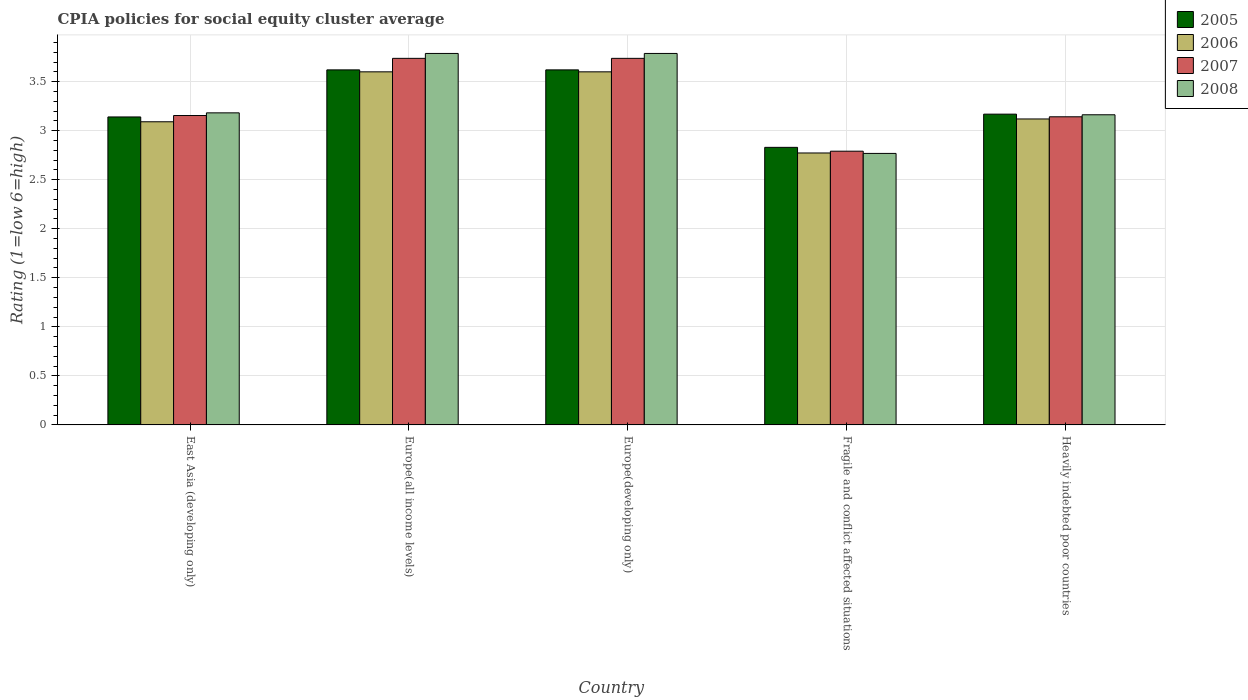How many different coloured bars are there?
Your response must be concise. 4. How many bars are there on the 4th tick from the left?
Provide a short and direct response. 4. How many bars are there on the 1st tick from the right?
Your answer should be compact. 4. What is the label of the 5th group of bars from the left?
Your response must be concise. Heavily indebted poor countries. In how many cases, is the number of bars for a given country not equal to the number of legend labels?
Offer a very short reply. 0. What is the CPIA rating in 2008 in Heavily indebted poor countries?
Provide a succinct answer. 3.16. Across all countries, what is the maximum CPIA rating in 2007?
Provide a short and direct response. 3.74. Across all countries, what is the minimum CPIA rating in 2006?
Your response must be concise. 2.77. In which country was the CPIA rating in 2008 maximum?
Offer a terse response. Europe(all income levels). In which country was the CPIA rating in 2005 minimum?
Offer a terse response. Fragile and conflict affected situations. What is the total CPIA rating in 2008 in the graph?
Make the answer very short. 16.69. What is the difference between the CPIA rating in 2006 in Europe(developing only) and that in Heavily indebted poor countries?
Ensure brevity in your answer.  0.48. What is the difference between the CPIA rating in 2008 in Europe(developing only) and the CPIA rating in 2006 in Fragile and conflict affected situations?
Your answer should be very brief. 1.01. What is the average CPIA rating in 2005 per country?
Give a very brief answer. 3.28. What is the difference between the CPIA rating of/in 2006 and CPIA rating of/in 2005 in Europe(developing only)?
Your answer should be compact. -0.02. What is the ratio of the CPIA rating in 2005 in East Asia (developing only) to that in Europe(developing only)?
Provide a short and direct response. 0.87. Is the CPIA rating in 2005 in East Asia (developing only) less than that in Europe(all income levels)?
Make the answer very short. Yes. Is the difference between the CPIA rating in 2006 in East Asia (developing only) and Europe(all income levels) greater than the difference between the CPIA rating in 2005 in East Asia (developing only) and Europe(all income levels)?
Your answer should be very brief. No. What is the difference between the highest and the second highest CPIA rating in 2005?
Provide a succinct answer. -0.45. What is the difference between the highest and the lowest CPIA rating in 2007?
Offer a very short reply. 0.95. Is the sum of the CPIA rating in 2005 in Europe(all income levels) and Europe(developing only) greater than the maximum CPIA rating in 2006 across all countries?
Make the answer very short. Yes. What does the 3rd bar from the left in Fragile and conflict affected situations represents?
Provide a short and direct response. 2007. Are all the bars in the graph horizontal?
Ensure brevity in your answer.  No. Does the graph contain any zero values?
Ensure brevity in your answer.  No. Does the graph contain grids?
Your answer should be compact. Yes. Where does the legend appear in the graph?
Offer a terse response. Top right. What is the title of the graph?
Offer a very short reply. CPIA policies for social equity cluster average. What is the label or title of the Y-axis?
Make the answer very short. Rating (1=low 6=high). What is the Rating (1=low 6=high) in 2005 in East Asia (developing only)?
Offer a very short reply. 3.14. What is the Rating (1=low 6=high) of 2006 in East Asia (developing only)?
Offer a terse response. 3.09. What is the Rating (1=low 6=high) of 2007 in East Asia (developing only)?
Ensure brevity in your answer.  3.15. What is the Rating (1=low 6=high) of 2008 in East Asia (developing only)?
Your answer should be compact. 3.18. What is the Rating (1=low 6=high) of 2005 in Europe(all income levels)?
Provide a short and direct response. 3.62. What is the Rating (1=low 6=high) of 2006 in Europe(all income levels)?
Your answer should be compact. 3.6. What is the Rating (1=low 6=high) in 2007 in Europe(all income levels)?
Your response must be concise. 3.74. What is the Rating (1=low 6=high) of 2008 in Europe(all income levels)?
Your response must be concise. 3.79. What is the Rating (1=low 6=high) of 2005 in Europe(developing only)?
Keep it short and to the point. 3.62. What is the Rating (1=low 6=high) of 2007 in Europe(developing only)?
Provide a short and direct response. 3.74. What is the Rating (1=low 6=high) in 2008 in Europe(developing only)?
Offer a terse response. 3.79. What is the Rating (1=low 6=high) of 2005 in Fragile and conflict affected situations?
Make the answer very short. 2.83. What is the Rating (1=low 6=high) of 2006 in Fragile and conflict affected situations?
Provide a succinct answer. 2.77. What is the Rating (1=low 6=high) of 2007 in Fragile and conflict affected situations?
Provide a short and direct response. 2.79. What is the Rating (1=low 6=high) in 2008 in Fragile and conflict affected situations?
Offer a very short reply. 2.77. What is the Rating (1=low 6=high) in 2005 in Heavily indebted poor countries?
Make the answer very short. 3.17. What is the Rating (1=low 6=high) in 2006 in Heavily indebted poor countries?
Provide a short and direct response. 3.12. What is the Rating (1=low 6=high) in 2007 in Heavily indebted poor countries?
Provide a succinct answer. 3.14. What is the Rating (1=low 6=high) of 2008 in Heavily indebted poor countries?
Offer a terse response. 3.16. Across all countries, what is the maximum Rating (1=low 6=high) of 2005?
Provide a succinct answer. 3.62. Across all countries, what is the maximum Rating (1=low 6=high) in 2007?
Ensure brevity in your answer.  3.74. Across all countries, what is the maximum Rating (1=low 6=high) of 2008?
Make the answer very short. 3.79. Across all countries, what is the minimum Rating (1=low 6=high) in 2005?
Make the answer very short. 2.83. Across all countries, what is the minimum Rating (1=low 6=high) of 2006?
Make the answer very short. 2.77. Across all countries, what is the minimum Rating (1=low 6=high) in 2007?
Keep it short and to the point. 2.79. Across all countries, what is the minimum Rating (1=low 6=high) in 2008?
Your answer should be compact. 2.77. What is the total Rating (1=low 6=high) of 2005 in the graph?
Offer a terse response. 16.38. What is the total Rating (1=low 6=high) in 2006 in the graph?
Ensure brevity in your answer.  16.18. What is the total Rating (1=low 6=high) of 2007 in the graph?
Ensure brevity in your answer.  16.56. What is the total Rating (1=low 6=high) of 2008 in the graph?
Offer a terse response. 16.69. What is the difference between the Rating (1=low 6=high) of 2005 in East Asia (developing only) and that in Europe(all income levels)?
Offer a terse response. -0.48. What is the difference between the Rating (1=low 6=high) in 2006 in East Asia (developing only) and that in Europe(all income levels)?
Provide a succinct answer. -0.51. What is the difference between the Rating (1=low 6=high) in 2007 in East Asia (developing only) and that in Europe(all income levels)?
Keep it short and to the point. -0.58. What is the difference between the Rating (1=low 6=high) in 2008 in East Asia (developing only) and that in Europe(all income levels)?
Your response must be concise. -0.61. What is the difference between the Rating (1=low 6=high) in 2005 in East Asia (developing only) and that in Europe(developing only)?
Keep it short and to the point. -0.48. What is the difference between the Rating (1=low 6=high) in 2006 in East Asia (developing only) and that in Europe(developing only)?
Ensure brevity in your answer.  -0.51. What is the difference between the Rating (1=low 6=high) in 2007 in East Asia (developing only) and that in Europe(developing only)?
Offer a terse response. -0.58. What is the difference between the Rating (1=low 6=high) in 2008 in East Asia (developing only) and that in Europe(developing only)?
Your answer should be compact. -0.61. What is the difference between the Rating (1=low 6=high) of 2005 in East Asia (developing only) and that in Fragile and conflict affected situations?
Your answer should be compact. 0.31. What is the difference between the Rating (1=low 6=high) in 2006 in East Asia (developing only) and that in Fragile and conflict affected situations?
Provide a short and direct response. 0.32. What is the difference between the Rating (1=low 6=high) in 2007 in East Asia (developing only) and that in Fragile and conflict affected situations?
Give a very brief answer. 0.36. What is the difference between the Rating (1=low 6=high) of 2008 in East Asia (developing only) and that in Fragile and conflict affected situations?
Keep it short and to the point. 0.41. What is the difference between the Rating (1=low 6=high) of 2005 in East Asia (developing only) and that in Heavily indebted poor countries?
Keep it short and to the point. -0.03. What is the difference between the Rating (1=low 6=high) in 2006 in East Asia (developing only) and that in Heavily indebted poor countries?
Make the answer very short. -0.03. What is the difference between the Rating (1=low 6=high) of 2007 in East Asia (developing only) and that in Heavily indebted poor countries?
Offer a terse response. 0.01. What is the difference between the Rating (1=low 6=high) in 2008 in East Asia (developing only) and that in Heavily indebted poor countries?
Give a very brief answer. 0.02. What is the difference between the Rating (1=low 6=high) of 2006 in Europe(all income levels) and that in Europe(developing only)?
Your answer should be very brief. 0. What is the difference between the Rating (1=low 6=high) of 2007 in Europe(all income levels) and that in Europe(developing only)?
Your answer should be very brief. 0. What is the difference between the Rating (1=low 6=high) of 2008 in Europe(all income levels) and that in Europe(developing only)?
Your response must be concise. 0. What is the difference between the Rating (1=low 6=high) of 2005 in Europe(all income levels) and that in Fragile and conflict affected situations?
Offer a very short reply. 0.79. What is the difference between the Rating (1=low 6=high) in 2006 in Europe(all income levels) and that in Fragile and conflict affected situations?
Make the answer very short. 0.83. What is the difference between the Rating (1=low 6=high) in 2007 in Europe(all income levels) and that in Fragile and conflict affected situations?
Make the answer very short. 0.95. What is the difference between the Rating (1=low 6=high) of 2008 in Europe(all income levels) and that in Fragile and conflict affected situations?
Your answer should be very brief. 1.02. What is the difference between the Rating (1=low 6=high) in 2005 in Europe(all income levels) and that in Heavily indebted poor countries?
Your response must be concise. 0.45. What is the difference between the Rating (1=low 6=high) in 2006 in Europe(all income levels) and that in Heavily indebted poor countries?
Your answer should be very brief. 0.48. What is the difference between the Rating (1=low 6=high) in 2007 in Europe(all income levels) and that in Heavily indebted poor countries?
Keep it short and to the point. 0.6. What is the difference between the Rating (1=low 6=high) of 2008 in Europe(all income levels) and that in Heavily indebted poor countries?
Give a very brief answer. 0.63. What is the difference between the Rating (1=low 6=high) in 2005 in Europe(developing only) and that in Fragile and conflict affected situations?
Offer a very short reply. 0.79. What is the difference between the Rating (1=low 6=high) of 2006 in Europe(developing only) and that in Fragile and conflict affected situations?
Your response must be concise. 0.83. What is the difference between the Rating (1=low 6=high) in 2007 in Europe(developing only) and that in Fragile and conflict affected situations?
Make the answer very short. 0.95. What is the difference between the Rating (1=low 6=high) in 2008 in Europe(developing only) and that in Fragile and conflict affected situations?
Keep it short and to the point. 1.02. What is the difference between the Rating (1=low 6=high) in 2005 in Europe(developing only) and that in Heavily indebted poor countries?
Make the answer very short. 0.45. What is the difference between the Rating (1=low 6=high) of 2006 in Europe(developing only) and that in Heavily indebted poor countries?
Make the answer very short. 0.48. What is the difference between the Rating (1=low 6=high) of 2007 in Europe(developing only) and that in Heavily indebted poor countries?
Keep it short and to the point. 0.6. What is the difference between the Rating (1=low 6=high) of 2008 in Europe(developing only) and that in Heavily indebted poor countries?
Your answer should be compact. 0.63. What is the difference between the Rating (1=low 6=high) of 2005 in Fragile and conflict affected situations and that in Heavily indebted poor countries?
Make the answer very short. -0.34. What is the difference between the Rating (1=low 6=high) of 2006 in Fragile and conflict affected situations and that in Heavily indebted poor countries?
Your response must be concise. -0.35. What is the difference between the Rating (1=low 6=high) in 2007 in Fragile and conflict affected situations and that in Heavily indebted poor countries?
Make the answer very short. -0.35. What is the difference between the Rating (1=low 6=high) in 2008 in Fragile and conflict affected situations and that in Heavily indebted poor countries?
Ensure brevity in your answer.  -0.39. What is the difference between the Rating (1=low 6=high) of 2005 in East Asia (developing only) and the Rating (1=low 6=high) of 2006 in Europe(all income levels)?
Provide a succinct answer. -0.46. What is the difference between the Rating (1=low 6=high) of 2005 in East Asia (developing only) and the Rating (1=low 6=high) of 2007 in Europe(all income levels)?
Your answer should be compact. -0.6. What is the difference between the Rating (1=low 6=high) of 2005 in East Asia (developing only) and the Rating (1=low 6=high) of 2008 in Europe(all income levels)?
Offer a very short reply. -0.65. What is the difference between the Rating (1=low 6=high) of 2006 in East Asia (developing only) and the Rating (1=low 6=high) of 2007 in Europe(all income levels)?
Ensure brevity in your answer.  -0.65. What is the difference between the Rating (1=low 6=high) of 2006 in East Asia (developing only) and the Rating (1=low 6=high) of 2008 in Europe(all income levels)?
Offer a terse response. -0.7. What is the difference between the Rating (1=low 6=high) of 2007 in East Asia (developing only) and the Rating (1=low 6=high) of 2008 in Europe(all income levels)?
Your answer should be compact. -0.63. What is the difference between the Rating (1=low 6=high) of 2005 in East Asia (developing only) and the Rating (1=low 6=high) of 2006 in Europe(developing only)?
Make the answer very short. -0.46. What is the difference between the Rating (1=low 6=high) of 2005 in East Asia (developing only) and the Rating (1=low 6=high) of 2007 in Europe(developing only)?
Provide a succinct answer. -0.6. What is the difference between the Rating (1=low 6=high) in 2005 in East Asia (developing only) and the Rating (1=low 6=high) in 2008 in Europe(developing only)?
Keep it short and to the point. -0.65. What is the difference between the Rating (1=low 6=high) of 2006 in East Asia (developing only) and the Rating (1=low 6=high) of 2007 in Europe(developing only)?
Make the answer very short. -0.65. What is the difference between the Rating (1=low 6=high) in 2006 in East Asia (developing only) and the Rating (1=low 6=high) in 2008 in Europe(developing only)?
Provide a succinct answer. -0.7. What is the difference between the Rating (1=low 6=high) in 2007 in East Asia (developing only) and the Rating (1=low 6=high) in 2008 in Europe(developing only)?
Make the answer very short. -0.63. What is the difference between the Rating (1=low 6=high) in 2005 in East Asia (developing only) and the Rating (1=low 6=high) in 2006 in Fragile and conflict affected situations?
Ensure brevity in your answer.  0.37. What is the difference between the Rating (1=low 6=high) of 2005 in East Asia (developing only) and the Rating (1=low 6=high) of 2007 in Fragile and conflict affected situations?
Ensure brevity in your answer.  0.35. What is the difference between the Rating (1=low 6=high) in 2005 in East Asia (developing only) and the Rating (1=low 6=high) in 2008 in Fragile and conflict affected situations?
Ensure brevity in your answer.  0.37. What is the difference between the Rating (1=low 6=high) in 2006 in East Asia (developing only) and the Rating (1=low 6=high) in 2008 in Fragile and conflict affected situations?
Keep it short and to the point. 0.32. What is the difference between the Rating (1=low 6=high) of 2007 in East Asia (developing only) and the Rating (1=low 6=high) of 2008 in Fragile and conflict affected situations?
Your answer should be very brief. 0.39. What is the difference between the Rating (1=low 6=high) of 2005 in East Asia (developing only) and the Rating (1=low 6=high) of 2006 in Heavily indebted poor countries?
Offer a terse response. 0.02. What is the difference between the Rating (1=low 6=high) in 2005 in East Asia (developing only) and the Rating (1=low 6=high) in 2007 in Heavily indebted poor countries?
Offer a terse response. -0. What is the difference between the Rating (1=low 6=high) in 2005 in East Asia (developing only) and the Rating (1=low 6=high) in 2008 in Heavily indebted poor countries?
Make the answer very short. -0.02. What is the difference between the Rating (1=low 6=high) in 2006 in East Asia (developing only) and the Rating (1=low 6=high) in 2007 in Heavily indebted poor countries?
Make the answer very short. -0.05. What is the difference between the Rating (1=low 6=high) of 2006 in East Asia (developing only) and the Rating (1=low 6=high) of 2008 in Heavily indebted poor countries?
Ensure brevity in your answer.  -0.07. What is the difference between the Rating (1=low 6=high) of 2007 in East Asia (developing only) and the Rating (1=low 6=high) of 2008 in Heavily indebted poor countries?
Give a very brief answer. -0.01. What is the difference between the Rating (1=low 6=high) of 2005 in Europe(all income levels) and the Rating (1=low 6=high) of 2006 in Europe(developing only)?
Your answer should be compact. 0.02. What is the difference between the Rating (1=low 6=high) in 2005 in Europe(all income levels) and the Rating (1=low 6=high) in 2007 in Europe(developing only)?
Offer a terse response. -0.12. What is the difference between the Rating (1=low 6=high) in 2005 in Europe(all income levels) and the Rating (1=low 6=high) in 2008 in Europe(developing only)?
Keep it short and to the point. -0.17. What is the difference between the Rating (1=low 6=high) in 2006 in Europe(all income levels) and the Rating (1=low 6=high) in 2007 in Europe(developing only)?
Provide a succinct answer. -0.14. What is the difference between the Rating (1=low 6=high) in 2006 in Europe(all income levels) and the Rating (1=low 6=high) in 2008 in Europe(developing only)?
Keep it short and to the point. -0.19. What is the difference between the Rating (1=low 6=high) in 2005 in Europe(all income levels) and the Rating (1=low 6=high) in 2006 in Fragile and conflict affected situations?
Your answer should be very brief. 0.85. What is the difference between the Rating (1=low 6=high) of 2005 in Europe(all income levels) and the Rating (1=low 6=high) of 2007 in Fragile and conflict affected situations?
Provide a short and direct response. 0.83. What is the difference between the Rating (1=low 6=high) of 2005 in Europe(all income levels) and the Rating (1=low 6=high) of 2008 in Fragile and conflict affected situations?
Your response must be concise. 0.85. What is the difference between the Rating (1=low 6=high) in 2006 in Europe(all income levels) and the Rating (1=low 6=high) in 2007 in Fragile and conflict affected situations?
Your answer should be very brief. 0.81. What is the difference between the Rating (1=low 6=high) in 2006 in Europe(all income levels) and the Rating (1=low 6=high) in 2008 in Fragile and conflict affected situations?
Offer a terse response. 0.83. What is the difference between the Rating (1=low 6=high) of 2007 in Europe(all income levels) and the Rating (1=low 6=high) of 2008 in Fragile and conflict affected situations?
Make the answer very short. 0.97. What is the difference between the Rating (1=low 6=high) in 2005 in Europe(all income levels) and the Rating (1=low 6=high) in 2006 in Heavily indebted poor countries?
Offer a very short reply. 0.5. What is the difference between the Rating (1=low 6=high) of 2005 in Europe(all income levels) and the Rating (1=low 6=high) of 2007 in Heavily indebted poor countries?
Ensure brevity in your answer.  0.48. What is the difference between the Rating (1=low 6=high) in 2005 in Europe(all income levels) and the Rating (1=low 6=high) in 2008 in Heavily indebted poor countries?
Ensure brevity in your answer.  0.46. What is the difference between the Rating (1=low 6=high) in 2006 in Europe(all income levels) and the Rating (1=low 6=high) in 2007 in Heavily indebted poor countries?
Offer a terse response. 0.46. What is the difference between the Rating (1=low 6=high) of 2006 in Europe(all income levels) and the Rating (1=low 6=high) of 2008 in Heavily indebted poor countries?
Your response must be concise. 0.44. What is the difference between the Rating (1=low 6=high) of 2007 in Europe(all income levels) and the Rating (1=low 6=high) of 2008 in Heavily indebted poor countries?
Provide a short and direct response. 0.58. What is the difference between the Rating (1=low 6=high) of 2005 in Europe(developing only) and the Rating (1=low 6=high) of 2006 in Fragile and conflict affected situations?
Keep it short and to the point. 0.85. What is the difference between the Rating (1=low 6=high) in 2005 in Europe(developing only) and the Rating (1=low 6=high) in 2007 in Fragile and conflict affected situations?
Make the answer very short. 0.83. What is the difference between the Rating (1=low 6=high) in 2005 in Europe(developing only) and the Rating (1=low 6=high) in 2008 in Fragile and conflict affected situations?
Your response must be concise. 0.85. What is the difference between the Rating (1=low 6=high) in 2006 in Europe(developing only) and the Rating (1=low 6=high) in 2007 in Fragile and conflict affected situations?
Provide a short and direct response. 0.81. What is the difference between the Rating (1=low 6=high) of 2006 in Europe(developing only) and the Rating (1=low 6=high) of 2008 in Fragile and conflict affected situations?
Provide a short and direct response. 0.83. What is the difference between the Rating (1=low 6=high) in 2007 in Europe(developing only) and the Rating (1=low 6=high) in 2008 in Fragile and conflict affected situations?
Your answer should be compact. 0.97. What is the difference between the Rating (1=low 6=high) in 2005 in Europe(developing only) and the Rating (1=low 6=high) in 2006 in Heavily indebted poor countries?
Ensure brevity in your answer.  0.5. What is the difference between the Rating (1=low 6=high) in 2005 in Europe(developing only) and the Rating (1=low 6=high) in 2007 in Heavily indebted poor countries?
Your answer should be very brief. 0.48. What is the difference between the Rating (1=low 6=high) of 2005 in Europe(developing only) and the Rating (1=low 6=high) of 2008 in Heavily indebted poor countries?
Your answer should be very brief. 0.46. What is the difference between the Rating (1=low 6=high) of 2006 in Europe(developing only) and the Rating (1=low 6=high) of 2007 in Heavily indebted poor countries?
Provide a short and direct response. 0.46. What is the difference between the Rating (1=low 6=high) of 2006 in Europe(developing only) and the Rating (1=low 6=high) of 2008 in Heavily indebted poor countries?
Keep it short and to the point. 0.44. What is the difference between the Rating (1=low 6=high) in 2007 in Europe(developing only) and the Rating (1=low 6=high) in 2008 in Heavily indebted poor countries?
Give a very brief answer. 0.58. What is the difference between the Rating (1=low 6=high) in 2005 in Fragile and conflict affected situations and the Rating (1=low 6=high) in 2006 in Heavily indebted poor countries?
Provide a short and direct response. -0.29. What is the difference between the Rating (1=low 6=high) in 2005 in Fragile and conflict affected situations and the Rating (1=low 6=high) in 2007 in Heavily indebted poor countries?
Your response must be concise. -0.31. What is the difference between the Rating (1=low 6=high) in 2005 in Fragile and conflict affected situations and the Rating (1=low 6=high) in 2008 in Heavily indebted poor countries?
Your answer should be very brief. -0.33. What is the difference between the Rating (1=low 6=high) of 2006 in Fragile and conflict affected situations and the Rating (1=low 6=high) of 2007 in Heavily indebted poor countries?
Give a very brief answer. -0.37. What is the difference between the Rating (1=low 6=high) in 2006 in Fragile and conflict affected situations and the Rating (1=low 6=high) in 2008 in Heavily indebted poor countries?
Offer a terse response. -0.39. What is the difference between the Rating (1=low 6=high) of 2007 in Fragile and conflict affected situations and the Rating (1=low 6=high) of 2008 in Heavily indebted poor countries?
Offer a terse response. -0.37. What is the average Rating (1=low 6=high) of 2005 per country?
Your response must be concise. 3.28. What is the average Rating (1=low 6=high) in 2006 per country?
Give a very brief answer. 3.24. What is the average Rating (1=low 6=high) in 2007 per country?
Provide a succinct answer. 3.31. What is the average Rating (1=low 6=high) of 2008 per country?
Make the answer very short. 3.34. What is the difference between the Rating (1=low 6=high) in 2005 and Rating (1=low 6=high) in 2006 in East Asia (developing only)?
Offer a terse response. 0.05. What is the difference between the Rating (1=low 6=high) in 2005 and Rating (1=low 6=high) in 2007 in East Asia (developing only)?
Make the answer very short. -0.01. What is the difference between the Rating (1=low 6=high) in 2005 and Rating (1=low 6=high) in 2008 in East Asia (developing only)?
Your answer should be very brief. -0.04. What is the difference between the Rating (1=low 6=high) in 2006 and Rating (1=low 6=high) in 2007 in East Asia (developing only)?
Your answer should be very brief. -0.06. What is the difference between the Rating (1=low 6=high) in 2006 and Rating (1=low 6=high) in 2008 in East Asia (developing only)?
Make the answer very short. -0.09. What is the difference between the Rating (1=low 6=high) of 2007 and Rating (1=low 6=high) of 2008 in East Asia (developing only)?
Your response must be concise. -0.03. What is the difference between the Rating (1=low 6=high) in 2005 and Rating (1=low 6=high) in 2007 in Europe(all income levels)?
Make the answer very short. -0.12. What is the difference between the Rating (1=low 6=high) of 2005 and Rating (1=low 6=high) of 2008 in Europe(all income levels)?
Give a very brief answer. -0.17. What is the difference between the Rating (1=low 6=high) in 2006 and Rating (1=low 6=high) in 2007 in Europe(all income levels)?
Offer a terse response. -0.14. What is the difference between the Rating (1=low 6=high) of 2006 and Rating (1=low 6=high) of 2008 in Europe(all income levels)?
Keep it short and to the point. -0.19. What is the difference between the Rating (1=low 6=high) of 2005 and Rating (1=low 6=high) of 2006 in Europe(developing only)?
Give a very brief answer. 0.02. What is the difference between the Rating (1=low 6=high) of 2005 and Rating (1=low 6=high) of 2007 in Europe(developing only)?
Your response must be concise. -0.12. What is the difference between the Rating (1=low 6=high) in 2005 and Rating (1=low 6=high) in 2008 in Europe(developing only)?
Ensure brevity in your answer.  -0.17. What is the difference between the Rating (1=low 6=high) of 2006 and Rating (1=low 6=high) of 2007 in Europe(developing only)?
Provide a succinct answer. -0.14. What is the difference between the Rating (1=low 6=high) in 2006 and Rating (1=low 6=high) in 2008 in Europe(developing only)?
Keep it short and to the point. -0.19. What is the difference between the Rating (1=low 6=high) in 2005 and Rating (1=low 6=high) in 2006 in Fragile and conflict affected situations?
Provide a succinct answer. 0.06. What is the difference between the Rating (1=low 6=high) of 2005 and Rating (1=low 6=high) of 2007 in Fragile and conflict affected situations?
Ensure brevity in your answer.  0.04. What is the difference between the Rating (1=low 6=high) of 2005 and Rating (1=low 6=high) of 2008 in Fragile and conflict affected situations?
Your response must be concise. 0.06. What is the difference between the Rating (1=low 6=high) in 2006 and Rating (1=low 6=high) in 2007 in Fragile and conflict affected situations?
Keep it short and to the point. -0.02. What is the difference between the Rating (1=low 6=high) in 2006 and Rating (1=low 6=high) in 2008 in Fragile and conflict affected situations?
Make the answer very short. 0. What is the difference between the Rating (1=low 6=high) in 2007 and Rating (1=low 6=high) in 2008 in Fragile and conflict affected situations?
Your answer should be compact. 0.02. What is the difference between the Rating (1=low 6=high) of 2005 and Rating (1=low 6=high) of 2006 in Heavily indebted poor countries?
Your answer should be very brief. 0.05. What is the difference between the Rating (1=low 6=high) in 2005 and Rating (1=low 6=high) in 2007 in Heavily indebted poor countries?
Your answer should be very brief. 0.03. What is the difference between the Rating (1=low 6=high) in 2005 and Rating (1=low 6=high) in 2008 in Heavily indebted poor countries?
Provide a succinct answer. 0.01. What is the difference between the Rating (1=low 6=high) of 2006 and Rating (1=low 6=high) of 2007 in Heavily indebted poor countries?
Provide a succinct answer. -0.02. What is the difference between the Rating (1=low 6=high) of 2006 and Rating (1=low 6=high) of 2008 in Heavily indebted poor countries?
Offer a terse response. -0.04. What is the difference between the Rating (1=low 6=high) of 2007 and Rating (1=low 6=high) of 2008 in Heavily indebted poor countries?
Give a very brief answer. -0.02. What is the ratio of the Rating (1=low 6=high) of 2005 in East Asia (developing only) to that in Europe(all income levels)?
Give a very brief answer. 0.87. What is the ratio of the Rating (1=low 6=high) in 2006 in East Asia (developing only) to that in Europe(all income levels)?
Keep it short and to the point. 0.86. What is the ratio of the Rating (1=low 6=high) in 2007 in East Asia (developing only) to that in Europe(all income levels)?
Your answer should be compact. 0.84. What is the ratio of the Rating (1=low 6=high) of 2008 in East Asia (developing only) to that in Europe(all income levels)?
Ensure brevity in your answer.  0.84. What is the ratio of the Rating (1=low 6=high) in 2005 in East Asia (developing only) to that in Europe(developing only)?
Keep it short and to the point. 0.87. What is the ratio of the Rating (1=low 6=high) of 2006 in East Asia (developing only) to that in Europe(developing only)?
Keep it short and to the point. 0.86. What is the ratio of the Rating (1=low 6=high) in 2007 in East Asia (developing only) to that in Europe(developing only)?
Your answer should be very brief. 0.84. What is the ratio of the Rating (1=low 6=high) in 2008 in East Asia (developing only) to that in Europe(developing only)?
Offer a terse response. 0.84. What is the ratio of the Rating (1=low 6=high) of 2005 in East Asia (developing only) to that in Fragile and conflict affected situations?
Your response must be concise. 1.11. What is the ratio of the Rating (1=low 6=high) of 2006 in East Asia (developing only) to that in Fragile and conflict affected situations?
Your answer should be compact. 1.11. What is the ratio of the Rating (1=low 6=high) of 2007 in East Asia (developing only) to that in Fragile and conflict affected situations?
Keep it short and to the point. 1.13. What is the ratio of the Rating (1=low 6=high) in 2008 in East Asia (developing only) to that in Fragile and conflict affected situations?
Offer a terse response. 1.15. What is the ratio of the Rating (1=low 6=high) of 2006 in East Asia (developing only) to that in Heavily indebted poor countries?
Provide a short and direct response. 0.99. What is the ratio of the Rating (1=low 6=high) in 2008 in East Asia (developing only) to that in Heavily indebted poor countries?
Keep it short and to the point. 1.01. What is the ratio of the Rating (1=low 6=high) of 2006 in Europe(all income levels) to that in Europe(developing only)?
Give a very brief answer. 1. What is the ratio of the Rating (1=low 6=high) in 2005 in Europe(all income levels) to that in Fragile and conflict affected situations?
Make the answer very short. 1.28. What is the ratio of the Rating (1=low 6=high) in 2006 in Europe(all income levels) to that in Fragile and conflict affected situations?
Your answer should be very brief. 1.3. What is the ratio of the Rating (1=low 6=high) in 2007 in Europe(all income levels) to that in Fragile and conflict affected situations?
Provide a short and direct response. 1.34. What is the ratio of the Rating (1=low 6=high) in 2008 in Europe(all income levels) to that in Fragile and conflict affected situations?
Provide a short and direct response. 1.37. What is the ratio of the Rating (1=low 6=high) of 2005 in Europe(all income levels) to that in Heavily indebted poor countries?
Give a very brief answer. 1.14. What is the ratio of the Rating (1=low 6=high) in 2006 in Europe(all income levels) to that in Heavily indebted poor countries?
Ensure brevity in your answer.  1.15. What is the ratio of the Rating (1=low 6=high) in 2007 in Europe(all income levels) to that in Heavily indebted poor countries?
Your response must be concise. 1.19. What is the ratio of the Rating (1=low 6=high) in 2008 in Europe(all income levels) to that in Heavily indebted poor countries?
Your answer should be compact. 1.2. What is the ratio of the Rating (1=low 6=high) of 2005 in Europe(developing only) to that in Fragile and conflict affected situations?
Offer a very short reply. 1.28. What is the ratio of the Rating (1=low 6=high) of 2006 in Europe(developing only) to that in Fragile and conflict affected situations?
Your answer should be compact. 1.3. What is the ratio of the Rating (1=low 6=high) of 2007 in Europe(developing only) to that in Fragile and conflict affected situations?
Offer a very short reply. 1.34. What is the ratio of the Rating (1=low 6=high) of 2008 in Europe(developing only) to that in Fragile and conflict affected situations?
Your answer should be compact. 1.37. What is the ratio of the Rating (1=low 6=high) in 2005 in Europe(developing only) to that in Heavily indebted poor countries?
Give a very brief answer. 1.14. What is the ratio of the Rating (1=low 6=high) in 2006 in Europe(developing only) to that in Heavily indebted poor countries?
Ensure brevity in your answer.  1.15. What is the ratio of the Rating (1=low 6=high) of 2007 in Europe(developing only) to that in Heavily indebted poor countries?
Keep it short and to the point. 1.19. What is the ratio of the Rating (1=low 6=high) of 2008 in Europe(developing only) to that in Heavily indebted poor countries?
Your response must be concise. 1.2. What is the ratio of the Rating (1=low 6=high) in 2005 in Fragile and conflict affected situations to that in Heavily indebted poor countries?
Ensure brevity in your answer.  0.89. What is the ratio of the Rating (1=low 6=high) in 2006 in Fragile and conflict affected situations to that in Heavily indebted poor countries?
Your answer should be very brief. 0.89. What is the ratio of the Rating (1=low 6=high) of 2007 in Fragile and conflict affected situations to that in Heavily indebted poor countries?
Provide a short and direct response. 0.89. What is the ratio of the Rating (1=low 6=high) of 2008 in Fragile and conflict affected situations to that in Heavily indebted poor countries?
Offer a very short reply. 0.88. What is the difference between the highest and the second highest Rating (1=low 6=high) of 2007?
Your answer should be compact. 0. What is the difference between the highest and the second highest Rating (1=low 6=high) in 2008?
Offer a very short reply. 0. What is the difference between the highest and the lowest Rating (1=low 6=high) of 2005?
Make the answer very short. 0.79. What is the difference between the highest and the lowest Rating (1=low 6=high) in 2006?
Make the answer very short. 0.83. What is the difference between the highest and the lowest Rating (1=low 6=high) of 2007?
Provide a short and direct response. 0.95. What is the difference between the highest and the lowest Rating (1=low 6=high) in 2008?
Ensure brevity in your answer.  1.02. 